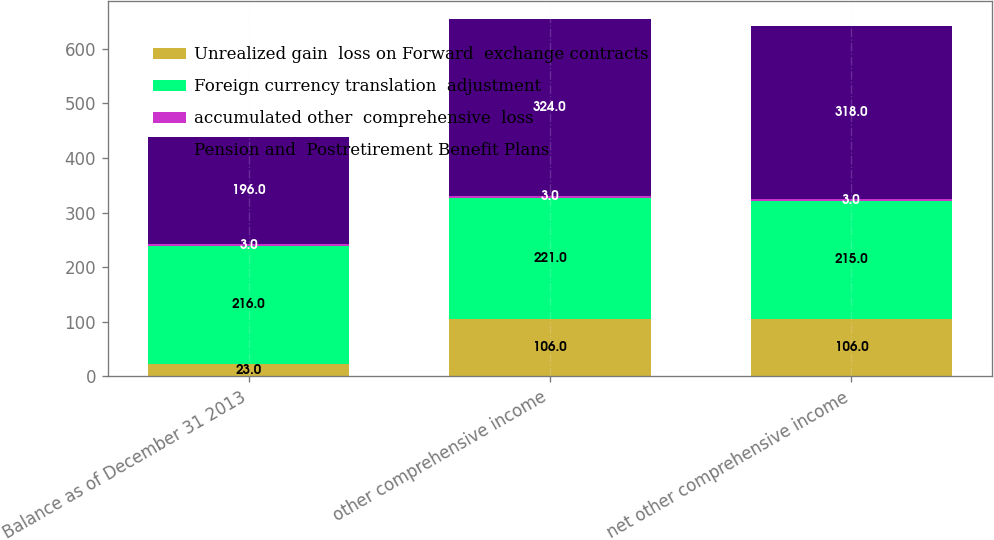Convert chart to OTSL. <chart><loc_0><loc_0><loc_500><loc_500><stacked_bar_chart><ecel><fcel>Balance as of December 31 2013<fcel>other comprehensive income<fcel>net other comprehensive income<nl><fcel>Unrealized gain  loss on Forward  exchange contracts<fcel>23<fcel>106<fcel>106<nl><fcel>Foreign currency translation  adjustment<fcel>216<fcel>221<fcel>215<nl><fcel>accumulated other  comprehensive  loss<fcel>3<fcel>3<fcel>3<nl><fcel>Pension and  Postretirement Benefit Plans<fcel>196<fcel>324<fcel>318<nl></chart> 